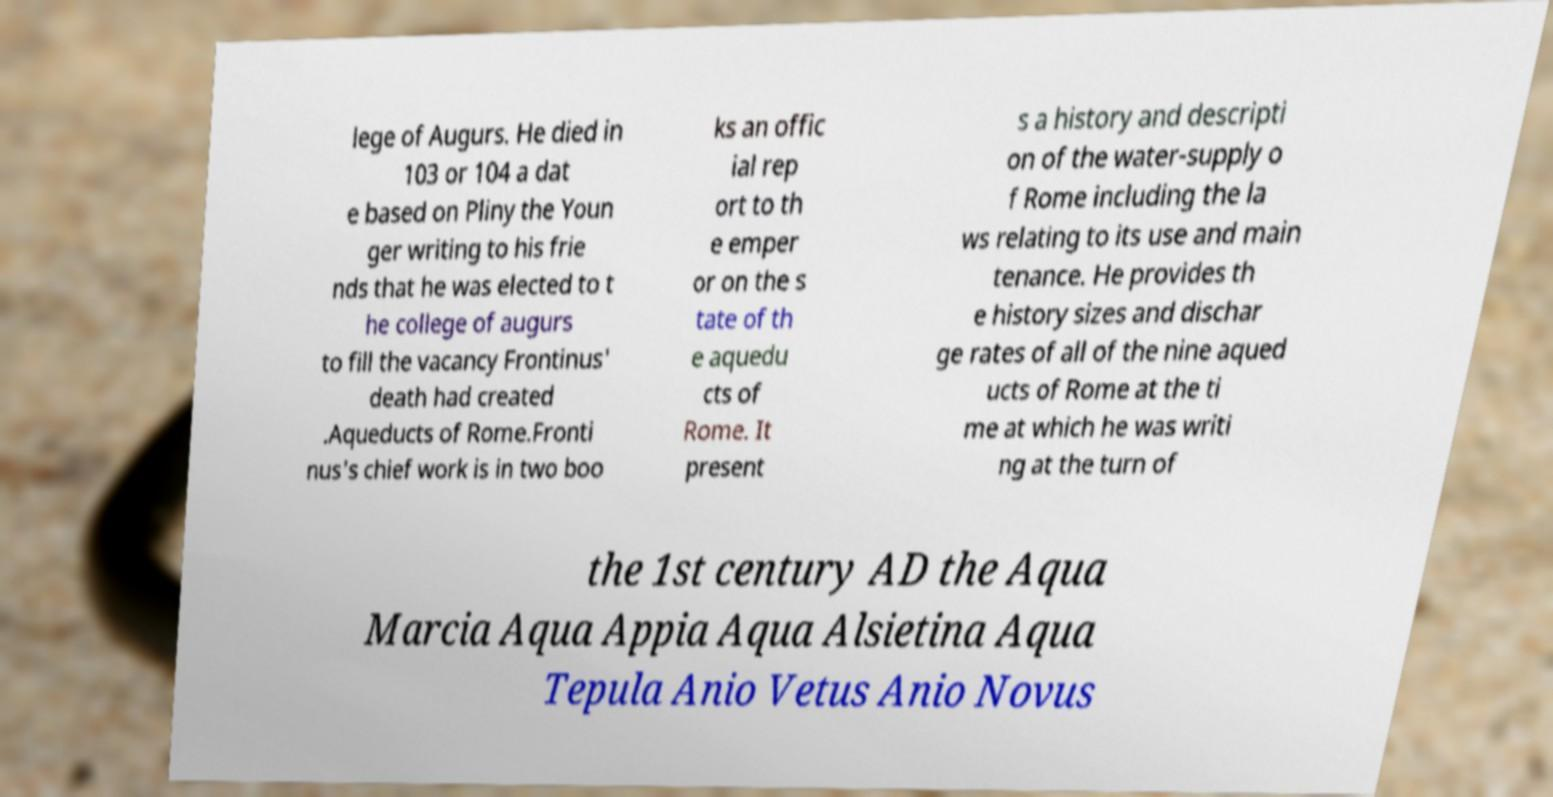There's text embedded in this image that I need extracted. Can you transcribe it verbatim? lege of Augurs. He died in 103 or 104 a dat e based on Pliny the Youn ger writing to his frie nds that he was elected to t he college of augurs to fill the vacancy Frontinus' death had created .Aqueducts of Rome.Fronti nus's chief work is in two boo ks an offic ial rep ort to th e emper or on the s tate of th e aquedu cts of Rome. It present s a history and descripti on of the water-supply o f Rome including the la ws relating to its use and main tenance. He provides th e history sizes and dischar ge rates of all of the nine aqued ucts of Rome at the ti me at which he was writi ng at the turn of the 1st century AD the Aqua Marcia Aqua Appia Aqua Alsietina Aqua Tepula Anio Vetus Anio Novus 